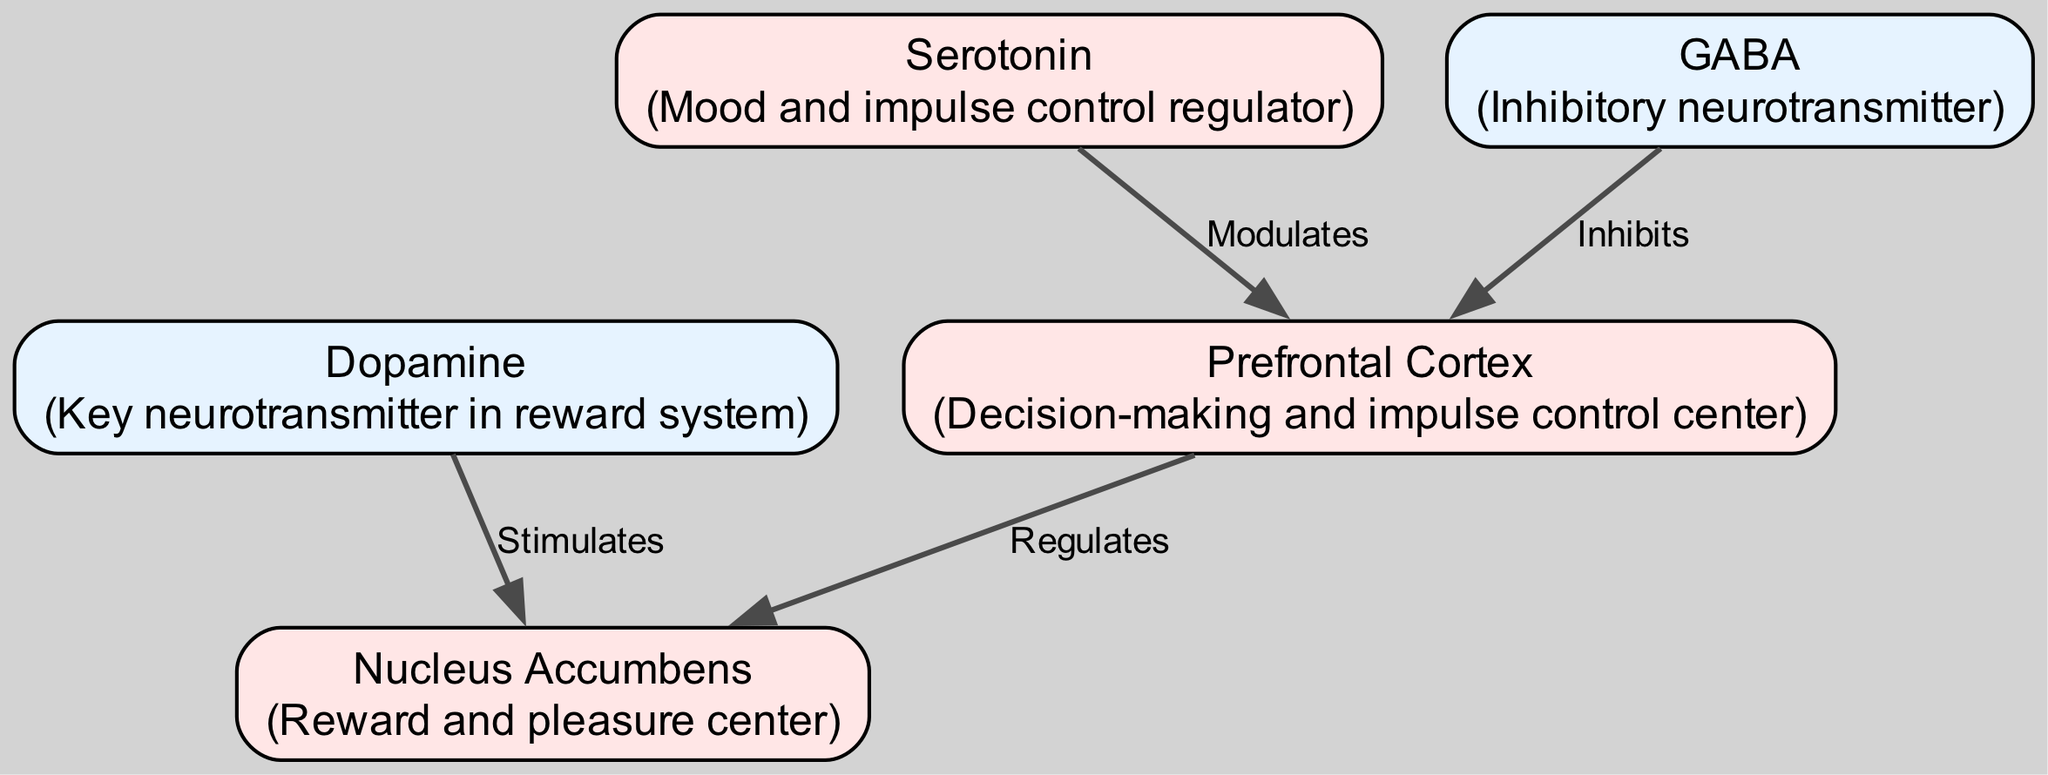What is the primary function of the Prefrontal Cortex? According to the diagram, the Prefrontal Cortex is described as the "Decision-making and impulse control center," which directly answers the function attributed to it.
Answer: Decision-making and impulse control center Which neurotransmitter is indicated as key in the reward system? The diagram labels Dopamine as "Key neurotransmitter in reward system," providing a clear identification of its importance in this context.
Answer: Dopamine How many nodes are present in the diagram? By counting the number of unique entities listed under "nodes," we find there are a total of 5 nodes (Prefrontal Cortex, Nucleus Accumbens, Dopamine, Serotonin, and GABA).
Answer: 5 What label describes the relationship from the Nucleus Accumbens to the Dopamine? The edge connecting Nucleus Accumbens and Dopamine is labeled "Stimulates," indicating the nature of their interaction as shown in the diagram.
Answer: Stimulates What regulatory role does Serotonin play in the Prefrontal Cortex? The diagram states that Serotonin "Modulates" the Prefrontal Cortex, indicating its influence on the functions of this brain region.
Answer: Modulates Which neurotransmitter is described as inhibitory? According to the description in the diagram, GABA is explicitly mentioned as the "Inhibitory neurotransmitter," which defines its functional characteristic.
Answer: GABA What effect does GABA have on the Prefrontal Cortex? The edge from GABA to the Prefrontal Cortex is labeled "Inhibits," which shows that GABA has a direct inhibitory effect on the activities of the Prefrontal Cortex.
Answer: Inhibits How does the Prefrontal Cortex relate to the Nucleus Accumbens? The diagram connects these two nodes with a relationship labeled "Regulates," indicating that the Prefrontal Cortex has a regulatory influence on the Nucleus Accumbens.
Answer: Regulates What is the description of the Nucleus Accumbens in the diagram? The diagram provides the description "Reward and pleasure center" for the Nucleus Accumbens, indicating its primary function within the context of the pathways.
Answer: Reward and pleasure center 